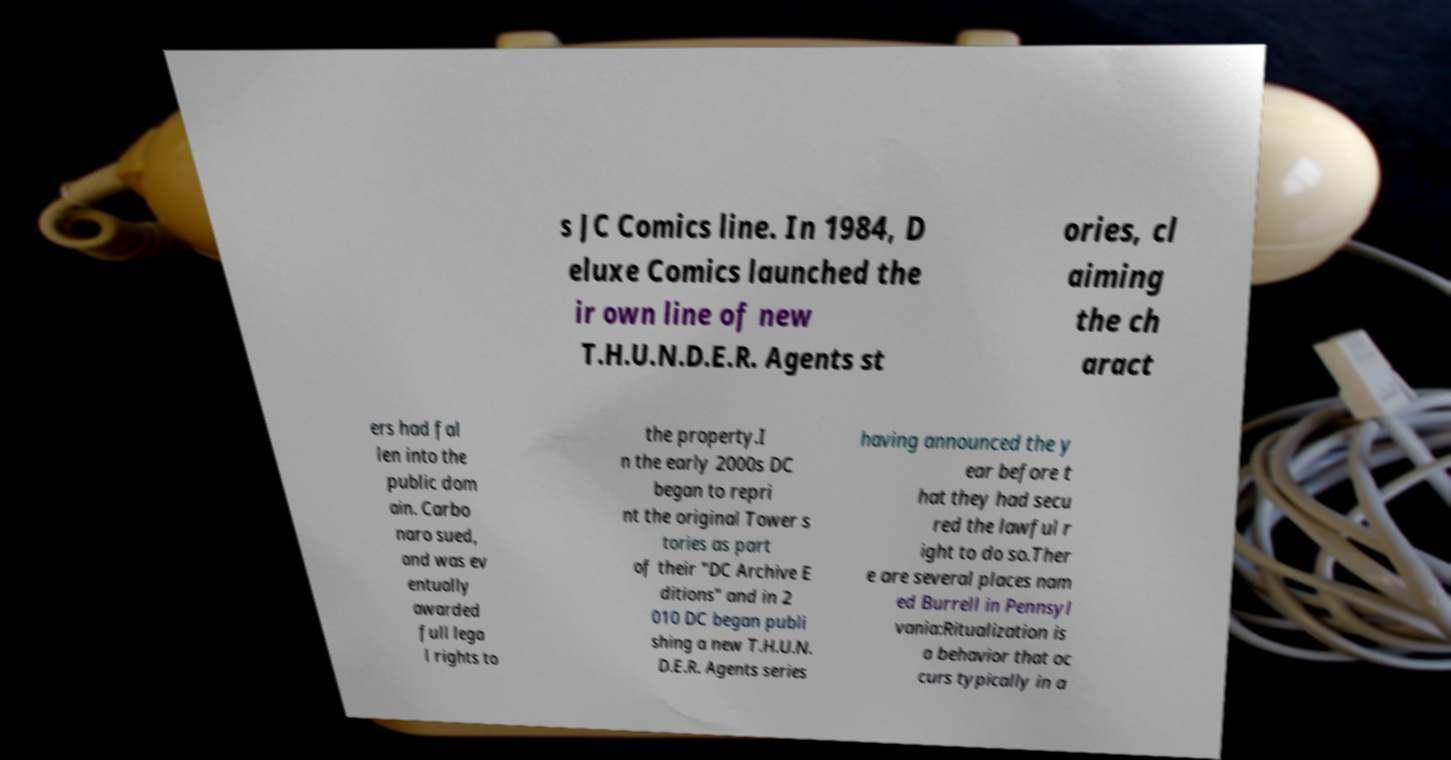Can you read and provide the text displayed in the image?This photo seems to have some interesting text. Can you extract and type it out for me? s JC Comics line. In 1984, D eluxe Comics launched the ir own line of new T.H.U.N.D.E.R. Agents st ories, cl aiming the ch aract ers had fal len into the public dom ain. Carbo naro sued, and was ev entually awarded full lega l rights to the property.I n the early 2000s DC began to repri nt the original Tower s tories as part of their "DC Archive E ditions" and in 2 010 DC began publi shing a new T.H.U.N. D.E.R. Agents series having announced the y ear before t hat they had secu red the lawful r ight to do so.Ther e are several places nam ed Burrell in Pennsyl vania:Ritualization is a behavior that oc curs typically in a 